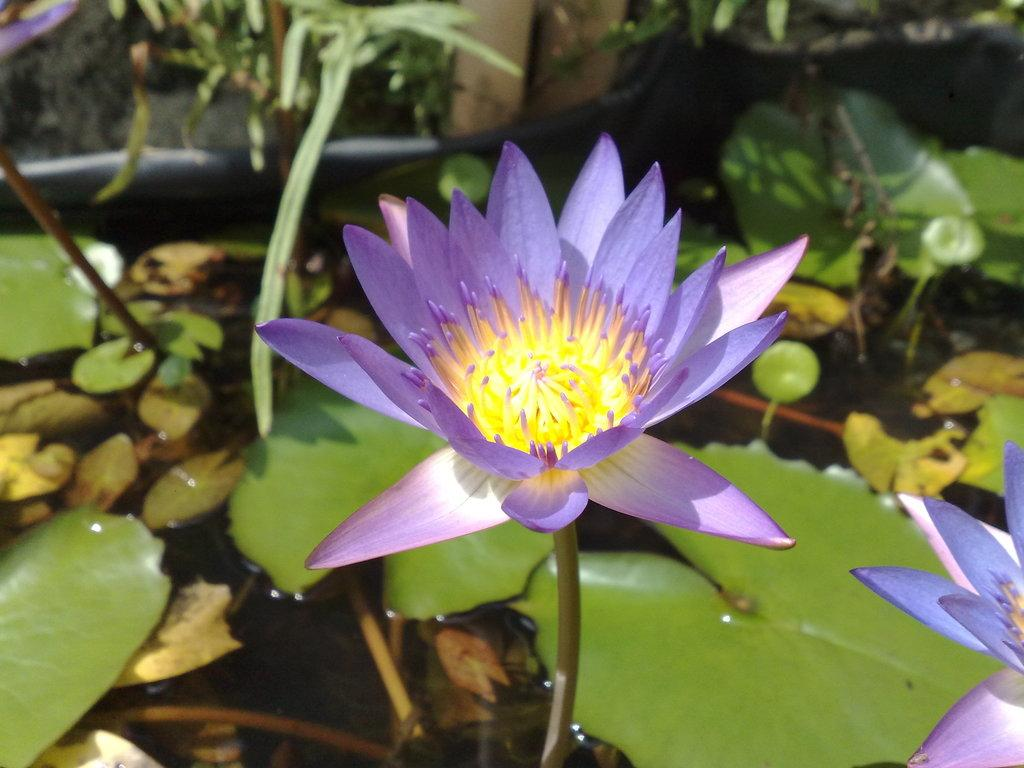What type of flower is in the image? There is a lotus flower in the image. What is the color of the lotus flower? The lotus flower is pale purple in color. Are there any other parts of the plant visible in the image? Yes, there are leaves associated with the lotus flower. What is the setting of the image? There is water visible in the image. Can you see a flame burning near the lotus flower in the image? No, there is no flame present in the image. Is there a hen walking among the lotus leaves in the image? No, there is no hen present in the image. 